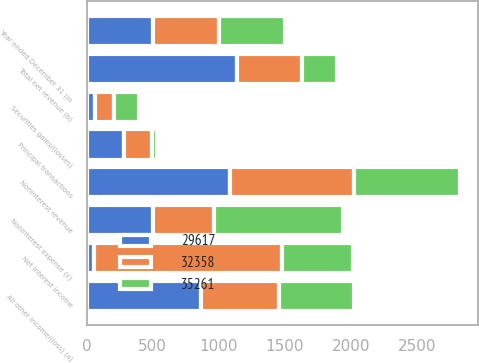Convert chart. <chart><loc_0><loc_0><loc_500><loc_500><stacked_bar_chart><ecel><fcel>Year ended December 31 (in<fcel>Principal transactions<fcel>Securities gains/(losses)<fcel>All other income/(loss) (a)<fcel>Noninterest revenue<fcel>Net interest income<fcel>Total net revenue (b)<fcel>Noninterest expense (c)<nl><fcel>29617<fcel>501<fcel>284<fcel>66<fcel>867<fcel>1085<fcel>55<fcel>1140<fcel>501<nl><fcel>32358<fcel>501<fcel>210<fcel>140<fcel>588<fcel>938<fcel>1425<fcel>487<fcel>462<nl><fcel>35261<fcel>501<fcel>41<fcel>190<fcel>569<fcel>800<fcel>533<fcel>267<fcel>977<nl></chart> 